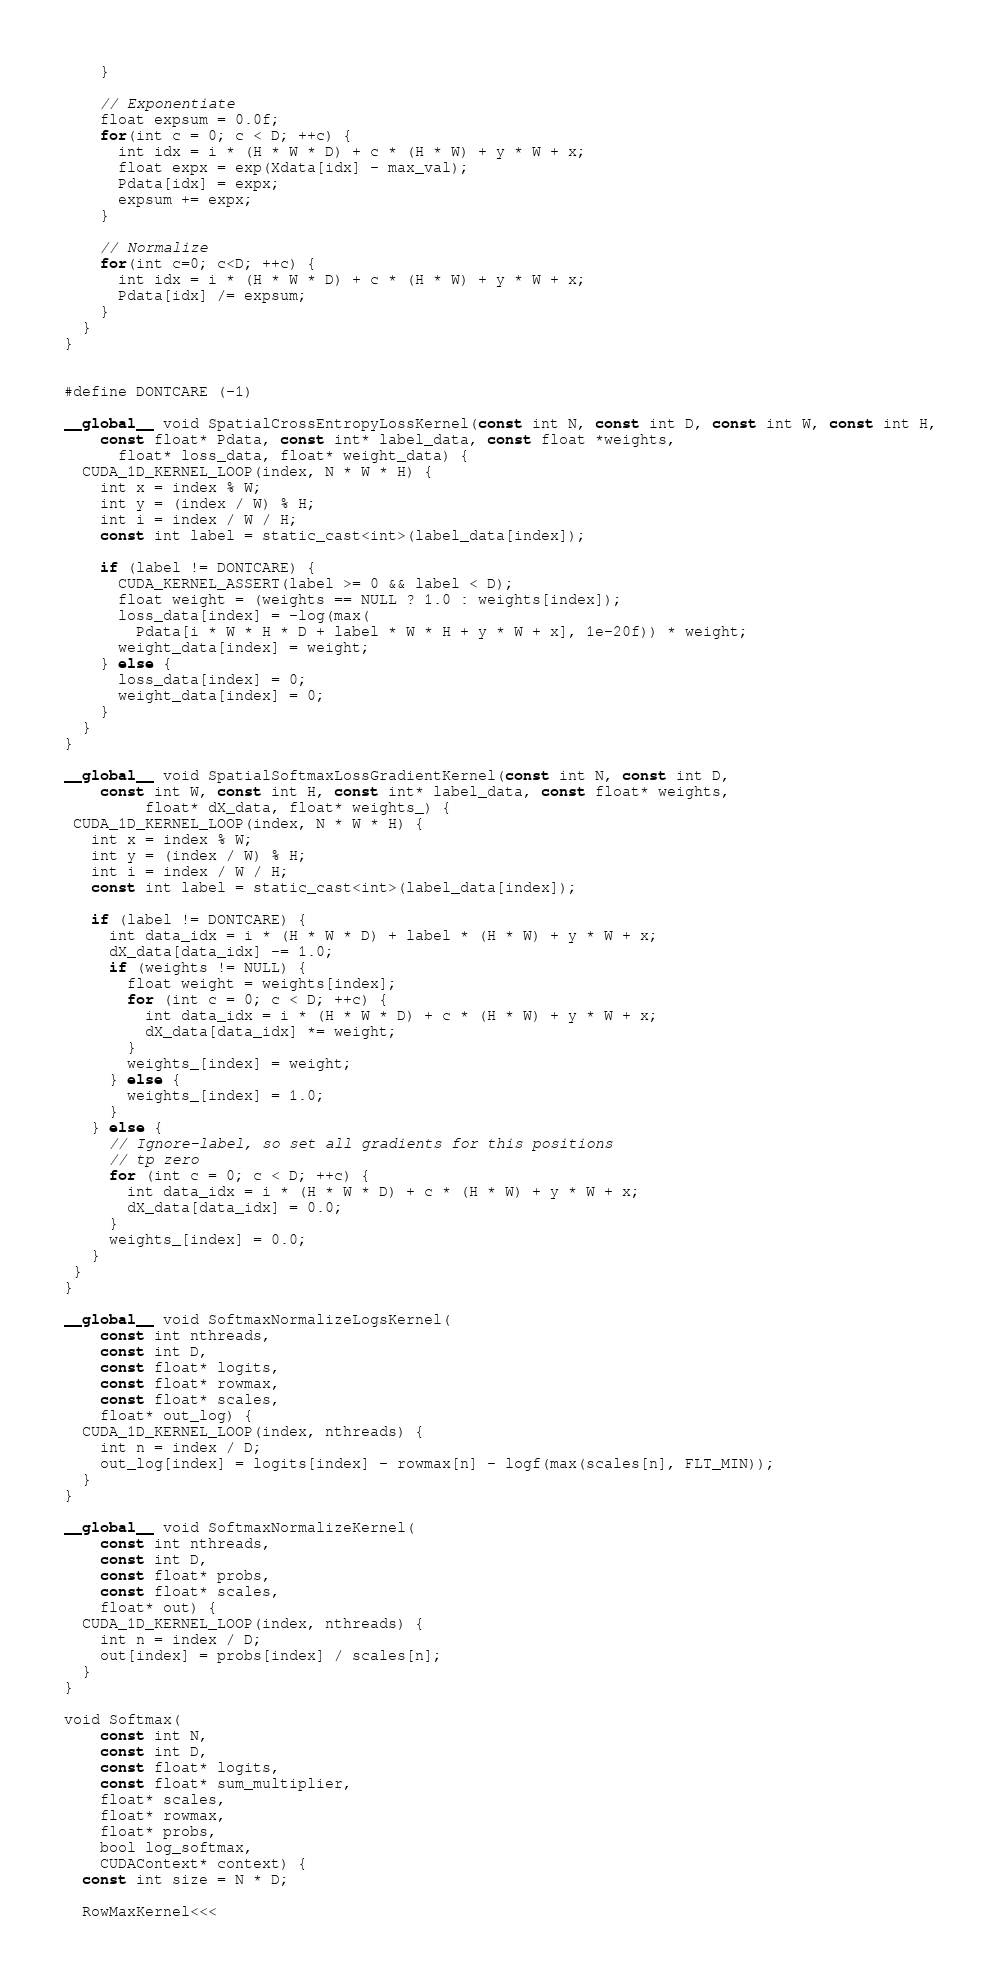<code> <loc_0><loc_0><loc_500><loc_500><_Cuda_>    }

    // Exponentiate
    float expsum = 0.0f;
    for(int c = 0; c < D; ++c) {
      int idx = i * (H * W * D) + c * (H * W) + y * W + x;
      float expx = exp(Xdata[idx] - max_val);
      Pdata[idx] = expx;
      expsum += expx;
    }

    // Normalize
    for(int c=0; c<D; ++c) {
      int idx = i * (H * W * D) + c * (H * W) + y * W + x;
      Pdata[idx] /= expsum;
    }
  }
}


#define DONTCARE (-1)

__global__ void SpatialCrossEntropyLossKernel(const int N, const int D, const int W, const int H,
    const float* Pdata, const int* label_data, const float *weights,
      float* loss_data, float* weight_data) {
  CUDA_1D_KERNEL_LOOP(index, N * W * H) {
    int x = index % W;
    int y = (index / W) % H;
    int i = index / W / H;
    const int label = static_cast<int>(label_data[index]);

    if (label != DONTCARE) {
      CUDA_KERNEL_ASSERT(label >= 0 && label < D);
      float weight = (weights == NULL ? 1.0 : weights[index]);
      loss_data[index] = -log(max(
        Pdata[i * W * H * D + label * W * H + y * W + x], 1e-20f)) * weight;
      weight_data[index] = weight;
    } else {
      loss_data[index] = 0;
      weight_data[index] = 0;
    }
  }
}

__global__ void SpatialSoftmaxLossGradientKernel(const int N, const int D,
    const int W, const int H, const int* label_data, const float* weights,
         float* dX_data, float* weights_) {
 CUDA_1D_KERNEL_LOOP(index, N * W * H) {
   int x = index % W;
   int y = (index / W) % H;
   int i = index / W / H;
   const int label = static_cast<int>(label_data[index]);

   if (label != DONTCARE) {
     int data_idx = i * (H * W * D) + label * (H * W) + y * W + x;
     dX_data[data_idx] -= 1.0;
     if (weights != NULL) {
       float weight = weights[index];
       for (int c = 0; c < D; ++c) {
         int data_idx = i * (H * W * D) + c * (H * W) + y * W + x;
         dX_data[data_idx] *= weight;
       }
       weights_[index] = weight;
     } else {
       weights_[index] = 1.0;
     }
   } else {
     // Ignore-label, so set all gradients for this positions
     // tp zero
     for (int c = 0; c < D; ++c) {
       int data_idx = i * (H * W * D) + c * (H * W) + y * W + x;
       dX_data[data_idx] = 0.0;
     }
     weights_[index] = 0.0;
   }
 }
}

__global__ void SoftmaxNormalizeLogsKernel(
    const int nthreads,
    const int D,
    const float* logits,
    const float* rowmax,
    const float* scales,
    float* out_log) {
  CUDA_1D_KERNEL_LOOP(index, nthreads) {
    int n = index / D;
    out_log[index] = logits[index] - rowmax[n] - logf(max(scales[n], FLT_MIN));
  }
}

__global__ void SoftmaxNormalizeKernel(
    const int nthreads,
    const int D,
    const float* probs,
    const float* scales,
    float* out) {
  CUDA_1D_KERNEL_LOOP(index, nthreads) {
    int n = index / D;
    out[index] = probs[index] / scales[n];
  }
}

void Softmax(
    const int N,
    const int D,
    const float* logits,
    const float* sum_multiplier,
    float* scales,
    float* rowmax,
    float* probs,
    bool log_softmax,
    CUDAContext* context) {
  const int size = N * D;

  RowMaxKernel<<<</code> 